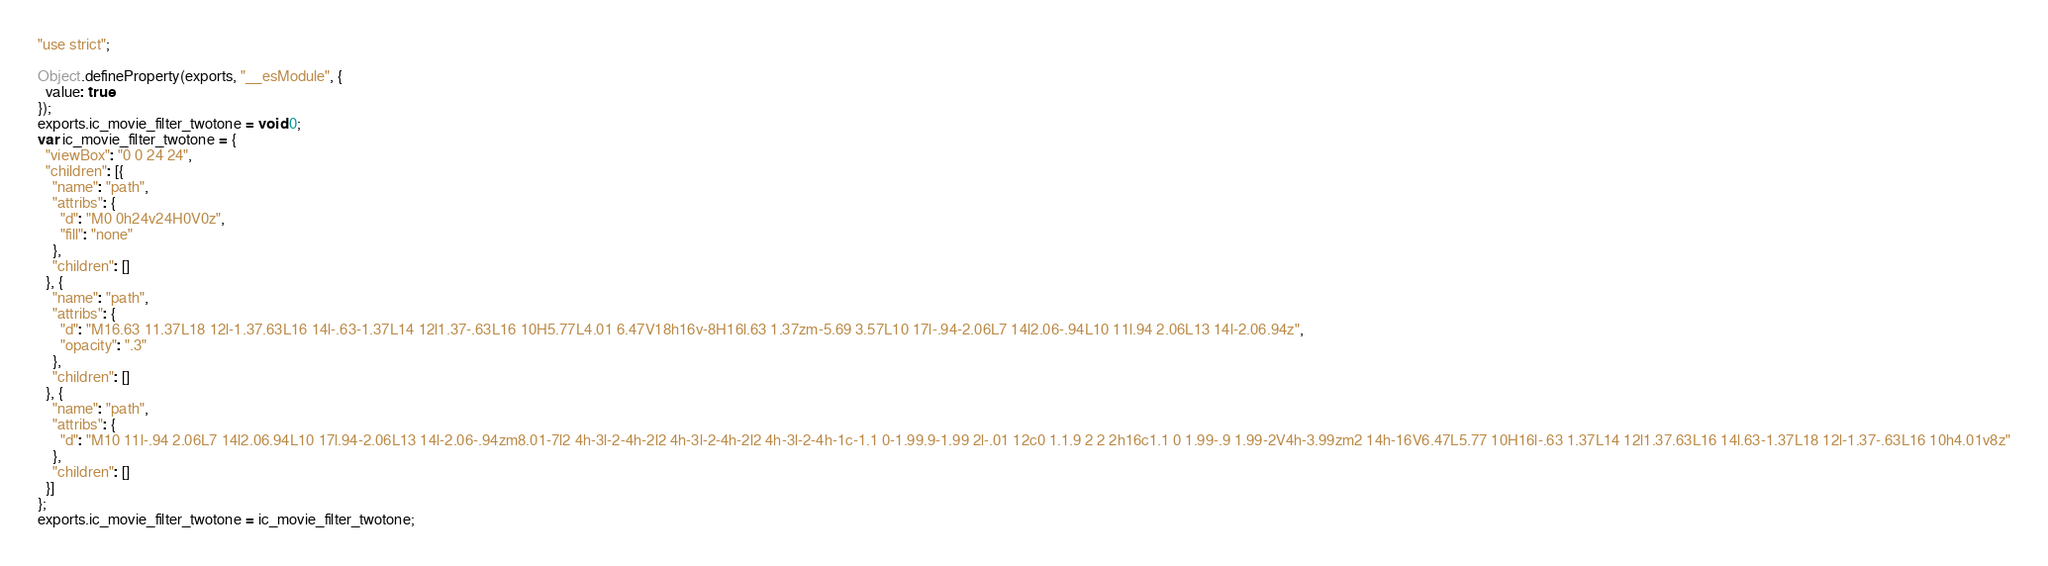<code> <loc_0><loc_0><loc_500><loc_500><_JavaScript_>"use strict";

Object.defineProperty(exports, "__esModule", {
  value: true
});
exports.ic_movie_filter_twotone = void 0;
var ic_movie_filter_twotone = {
  "viewBox": "0 0 24 24",
  "children": [{
    "name": "path",
    "attribs": {
      "d": "M0 0h24v24H0V0z",
      "fill": "none"
    },
    "children": []
  }, {
    "name": "path",
    "attribs": {
      "d": "M16.63 11.37L18 12l-1.37.63L16 14l-.63-1.37L14 12l1.37-.63L16 10H5.77L4.01 6.47V18h16v-8H16l.63 1.37zm-5.69 3.57L10 17l-.94-2.06L7 14l2.06-.94L10 11l.94 2.06L13 14l-2.06.94z",
      "opacity": ".3"
    },
    "children": []
  }, {
    "name": "path",
    "attribs": {
      "d": "M10 11l-.94 2.06L7 14l2.06.94L10 17l.94-2.06L13 14l-2.06-.94zm8.01-7l2 4h-3l-2-4h-2l2 4h-3l-2-4h-2l2 4h-3l-2-4h-1c-1.1 0-1.99.9-1.99 2l-.01 12c0 1.1.9 2 2 2h16c1.1 0 1.99-.9 1.99-2V4h-3.99zm2 14h-16V6.47L5.77 10H16l-.63 1.37L14 12l1.37.63L16 14l.63-1.37L18 12l-1.37-.63L16 10h4.01v8z"
    },
    "children": []
  }]
};
exports.ic_movie_filter_twotone = ic_movie_filter_twotone;</code> 